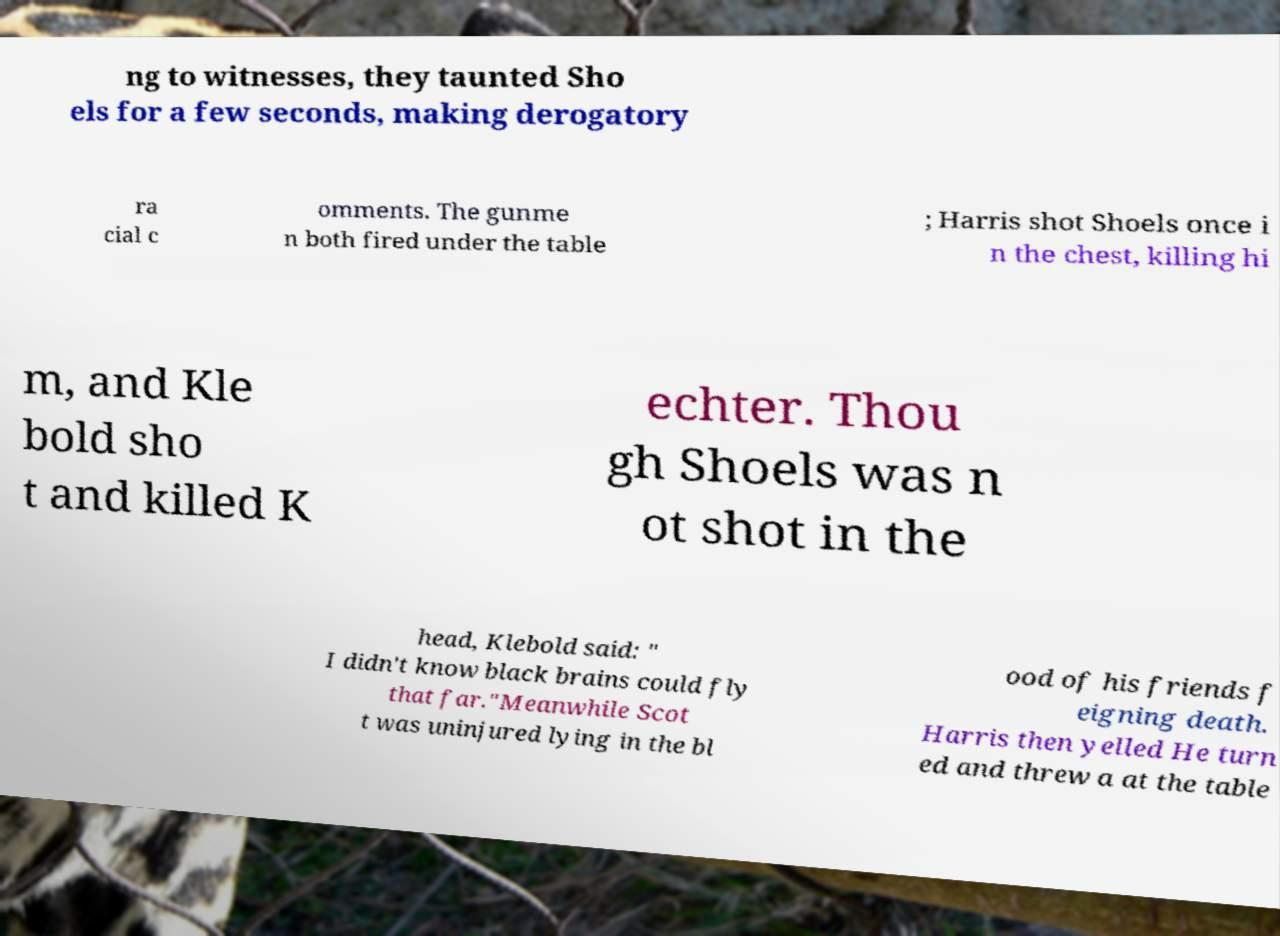Could you extract and type out the text from this image? ng to witnesses, they taunted Sho els for a few seconds, making derogatory ra cial c omments. The gunme n both fired under the table ; Harris shot Shoels once i n the chest, killing hi m, and Kle bold sho t and killed K echter. Thou gh Shoels was n ot shot in the head, Klebold said: " I didn't know black brains could fly that far."Meanwhile Scot t was uninjured lying in the bl ood of his friends f eigning death. Harris then yelled He turn ed and threw a at the table 